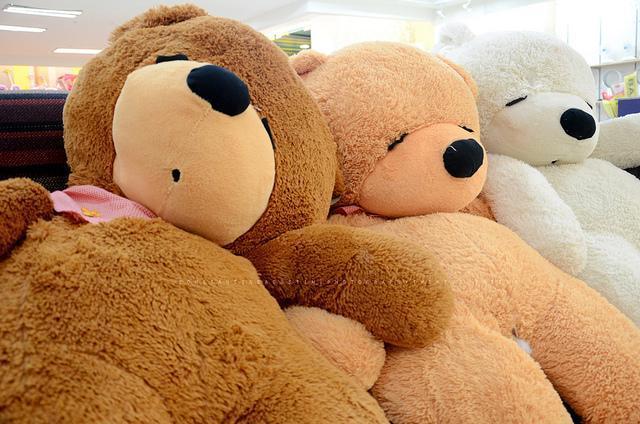How many bears are in the picture?
Give a very brief answer. 3. How many teddy bears are there?
Give a very brief answer. 3. How many teddy bears can be seen?
Give a very brief answer. 3. 